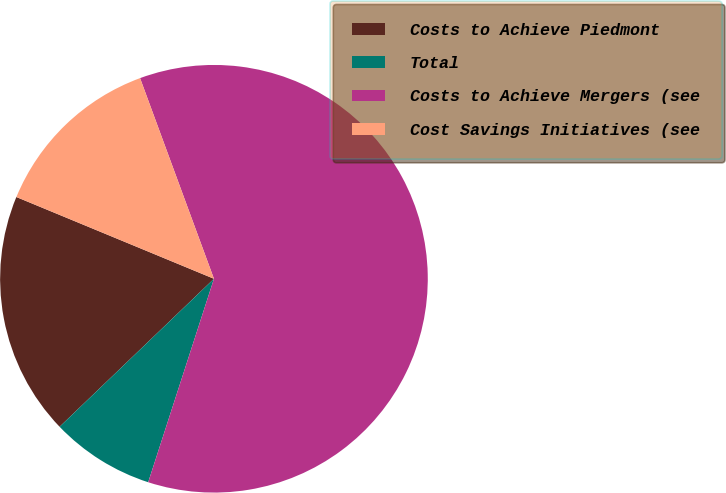Convert chart. <chart><loc_0><loc_0><loc_500><loc_500><pie_chart><fcel>Costs to Achieve Piedmont<fcel>Total<fcel>Costs to Achieve Mergers (see<fcel>Cost Savings Initiatives (see<nl><fcel>18.41%<fcel>7.86%<fcel>60.59%<fcel>13.14%<nl></chart> 